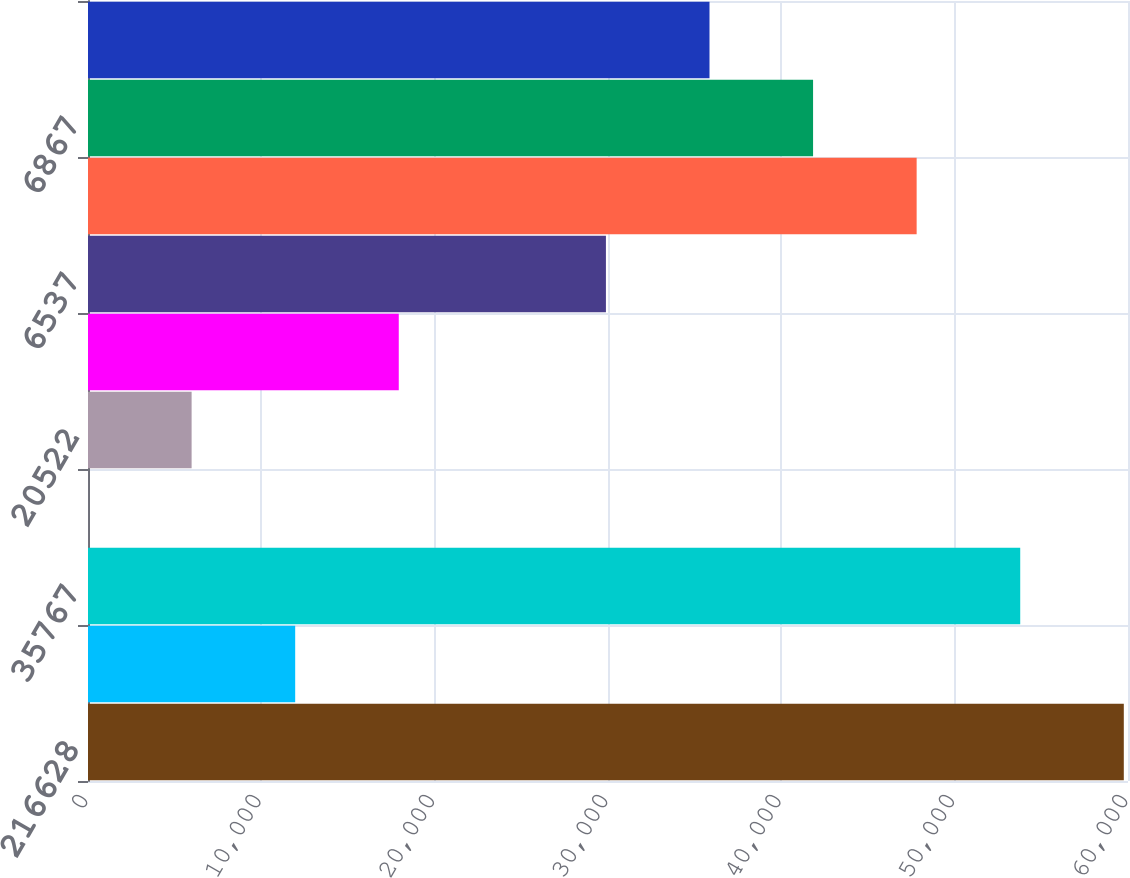Convert chart. <chart><loc_0><loc_0><loc_500><loc_500><bar_chart><fcel>216628<fcel>1834<fcel>35767<fcel>474<fcel>20522<fcel>1561<fcel>6537<fcel>40486<fcel>6867<fcel>6549<nl><fcel>59758<fcel>11953.2<fcel>53782.4<fcel>2.07<fcel>5977.66<fcel>17928.8<fcel>29880<fcel>47806.8<fcel>41831.2<fcel>35855.6<nl></chart> 